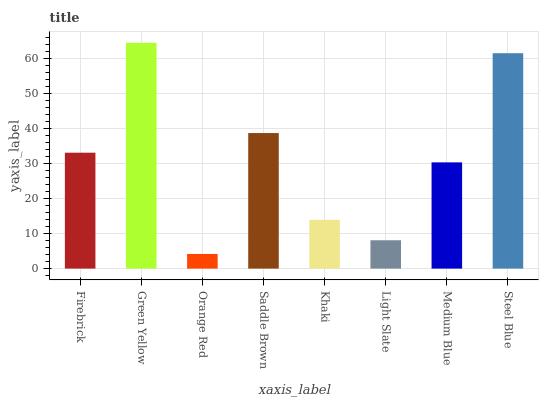Is Green Yellow the minimum?
Answer yes or no. No. Is Orange Red the maximum?
Answer yes or no. No. Is Green Yellow greater than Orange Red?
Answer yes or no. Yes. Is Orange Red less than Green Yellow?
Answer yes or no. Yes. Is Orange Red greater than Green Yellow?
Answer yes or no. No. Is Green Yellow less than Orange Red?
Answer yes or no. No. Is Firebrick the high median?
Answer yes or no. Yes. Is Medium Blue the low median?
Answer yes or no. Yes. Is Medium Blue the high median?
Answer yes or no. No. Is Green Yellow the low median?
Answer yes or no. No. 